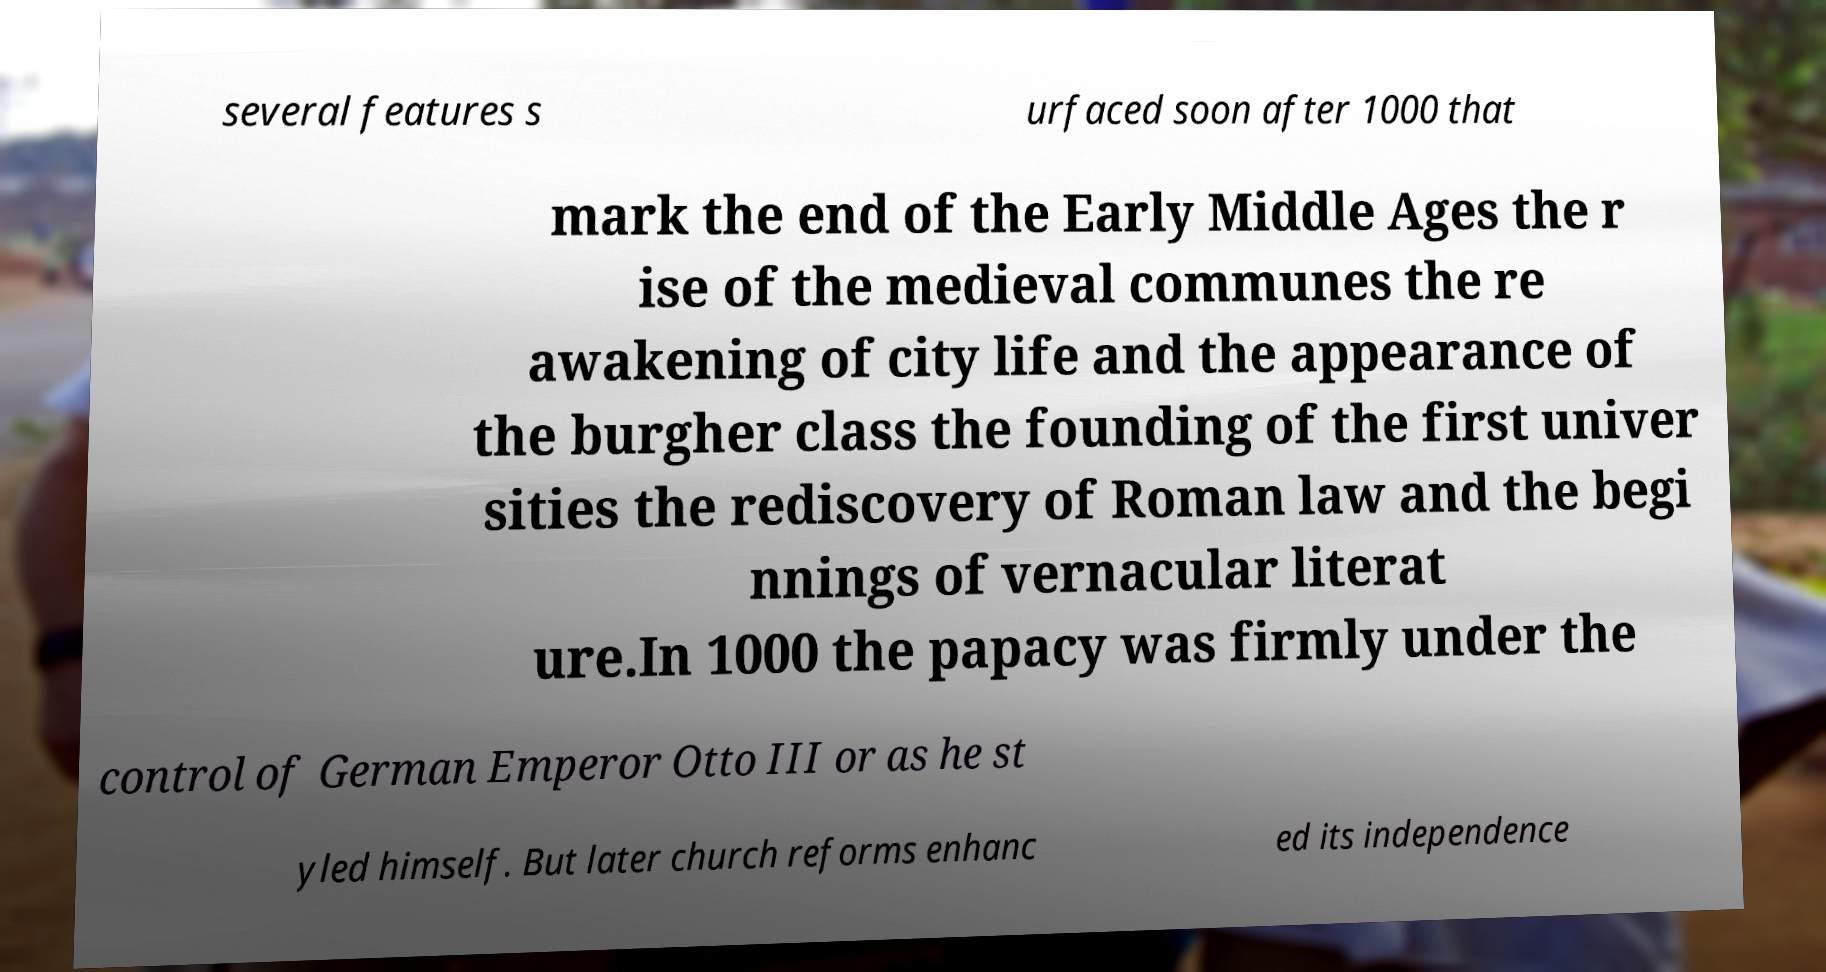Can you accurately transcribe the text from the provided image for me? several features s urfaced soon after 1000 that mark the end of the Early Middle Ages the r ise of the medieval communes the re awakening of city life and the appearance of the burgher class the founding of the first univer sities the rediscovery of Roman law and the begi nnings of vernacular literat ure.In 1000 the papacy was firmly under the control of German Emperor Otto III or as he st yled himself. But later church reforms enhanc ed its independence 